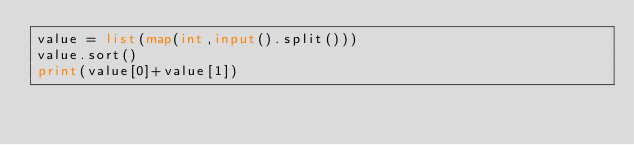<code> <loc_0><loc_0><loc_500><loc_500><_Python_>value = list(map(int,input().split()))
value.sort()
print(value[0]+value[1])</code> 